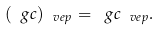Convert formula to latex. <formula><loc_0><loc_0><loc_500><loc_500>( \ g c ) _ { \ v e p } = \ g c _ { \ v e p } .</formula> 